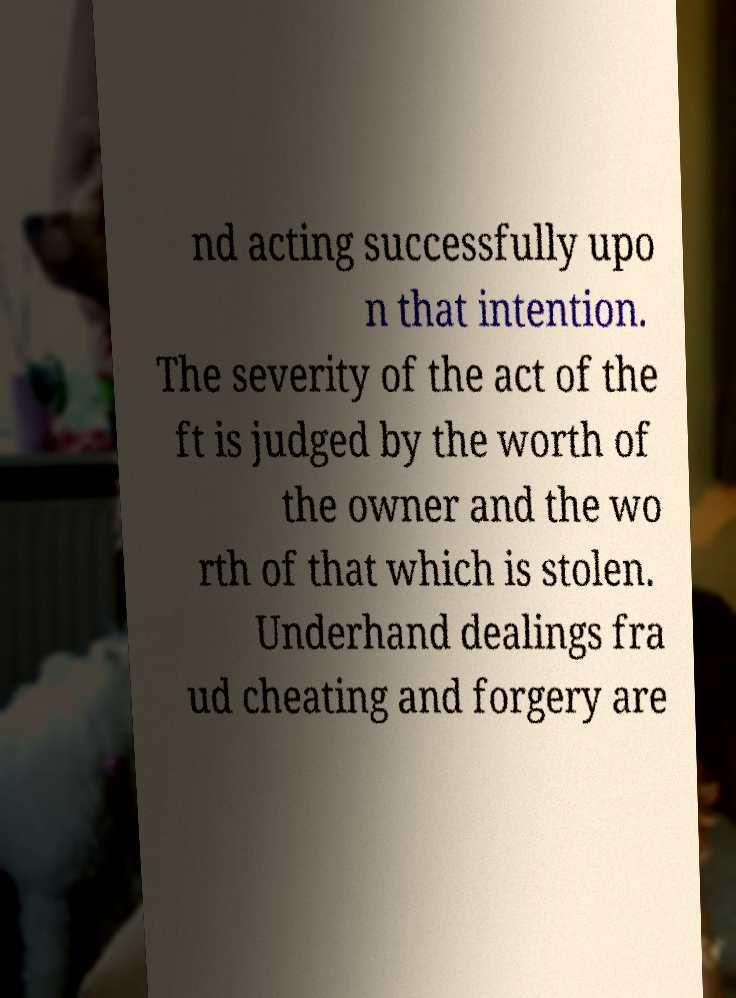For documentation purposes, I need the text within this image transcribed. Could you provide that? nd acting successfully upo n that intention. The severity of the act of the ft is judged by the worth of the owner and the wo rth of that which is stolen. Underhand dealings fra ud cheating and forgery are 